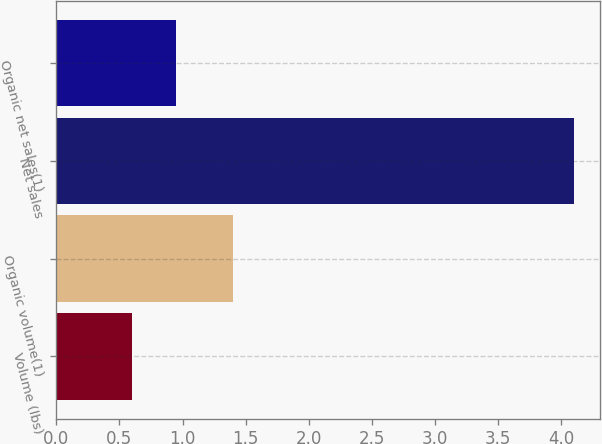Convert chart to OTSL. <chart><loc_0><loc_0><loc_500><loc_500><bar_chart><fcel>Volume (lbs)<fcel>Organic volume(1)<fcel>Net sales<fcel>Organic net sales(1)<nl><fcel>0.6<fcel>1.4<fcel>4.1<fcel>0.95<nl></chart> 